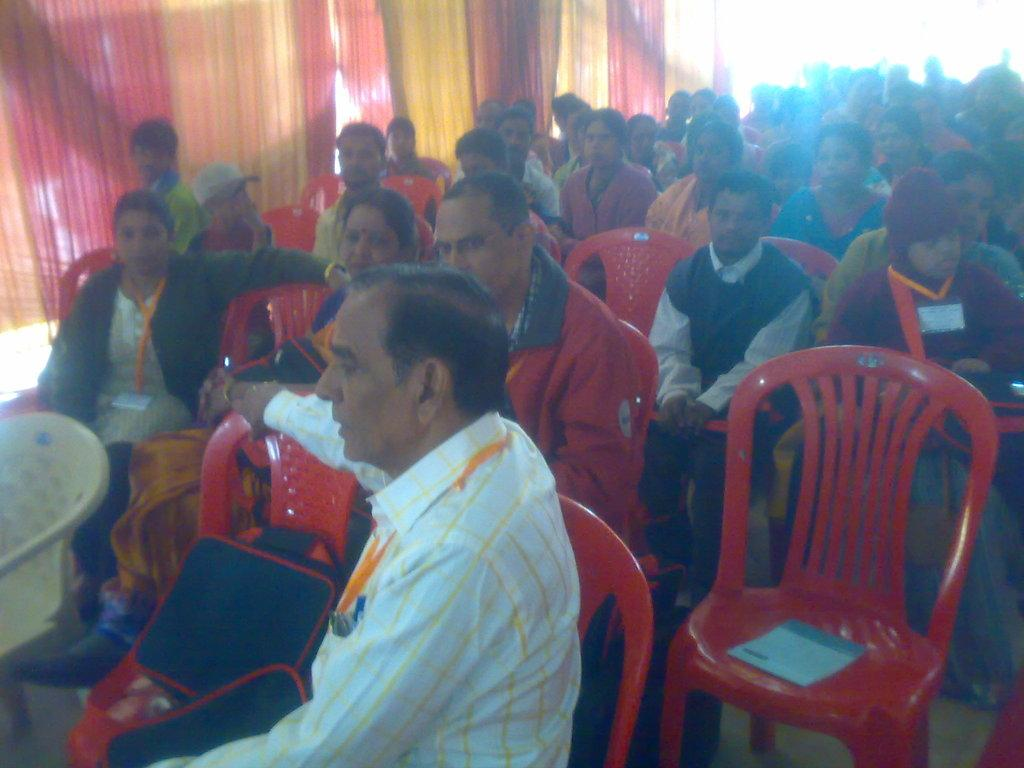What are the people in the image doing? The people in the image are sitting in chairs. Are all the chairs occupied? No, some chairs are empty. Can you describe the composition of the group? There are men and women in the group. What type of detail can be seen on the baby's clothing in the image? There is no baby present in the image, so there are no details on a baby's clothing to observe. 